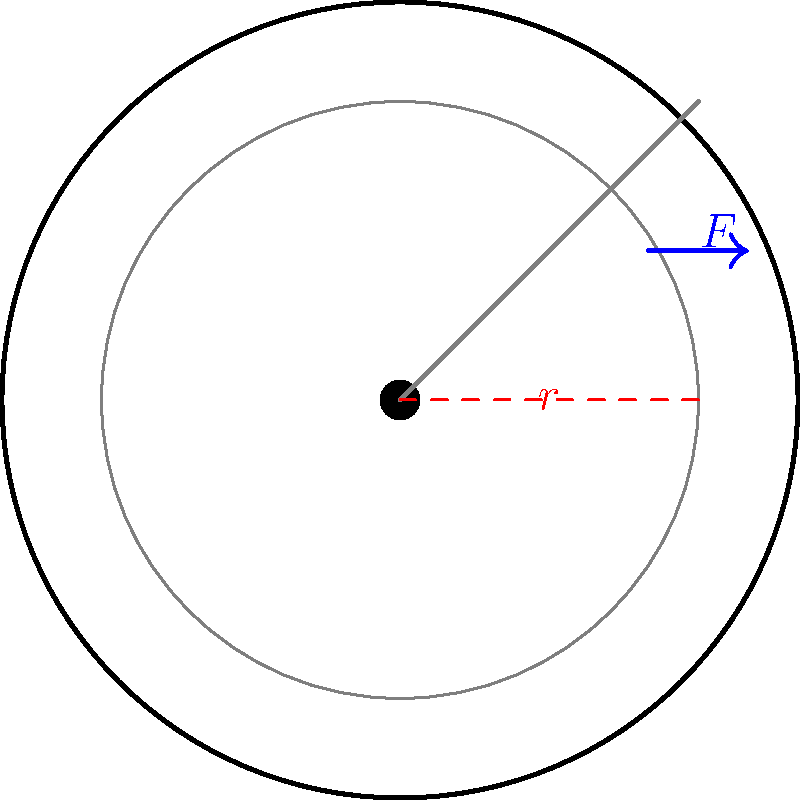As you're designing album art for a local Detroit musician, you become curious about the mechanics of vinyl playback. If a turntable applies a tangential force of 0.05 N at the edge of a 12-inch diameter vinyl record, what is the torque required to rotate the record? Assume the force is applied perpendicular to the radius. To solve this problem, we'll use the formula for torque:

$$\tau = F \cdot r$$

Where:
$\tau$ = torque
$F$ = force applied
$r$ = radius (distance from the center of rotation to the point where force is applied)

Step 1: Convert the diameter to radius in meters
Diameter = 12 inches = 0.3048 meters
Radius = Diameter ÷ 2 = 0.3048 ÷ 2 = 0.1524 meters

Step 2: Identify the given force
$F = 0.05$ N

Step 3: Apply the torque formula
$$\tau = F \cdot r$$
$$\tau = 0.05 \text{ N} \cdot 0.1524 \text{ m}$$
$$\tau = 0.00762 \text{ N⋅m}$$

Step 4: Round to three significant figures
$$\tau \approx 0.00762 \text{ N⋅m} = 7.62 \times 10^{-3} \text{ N⋅m}$$
Answer: $7.62 \times 10^{-3} \text{ N⋅m}$ 